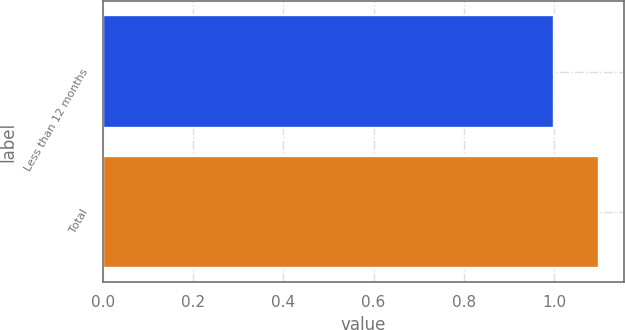Convert chart to OTSL. <chart><loc_0><loc_0><loc_500><loc_500><bar_chart><fcel>Less than 12 months<fcel>Total<nl><fcel>1<fcel>1.1<nl></chart> 